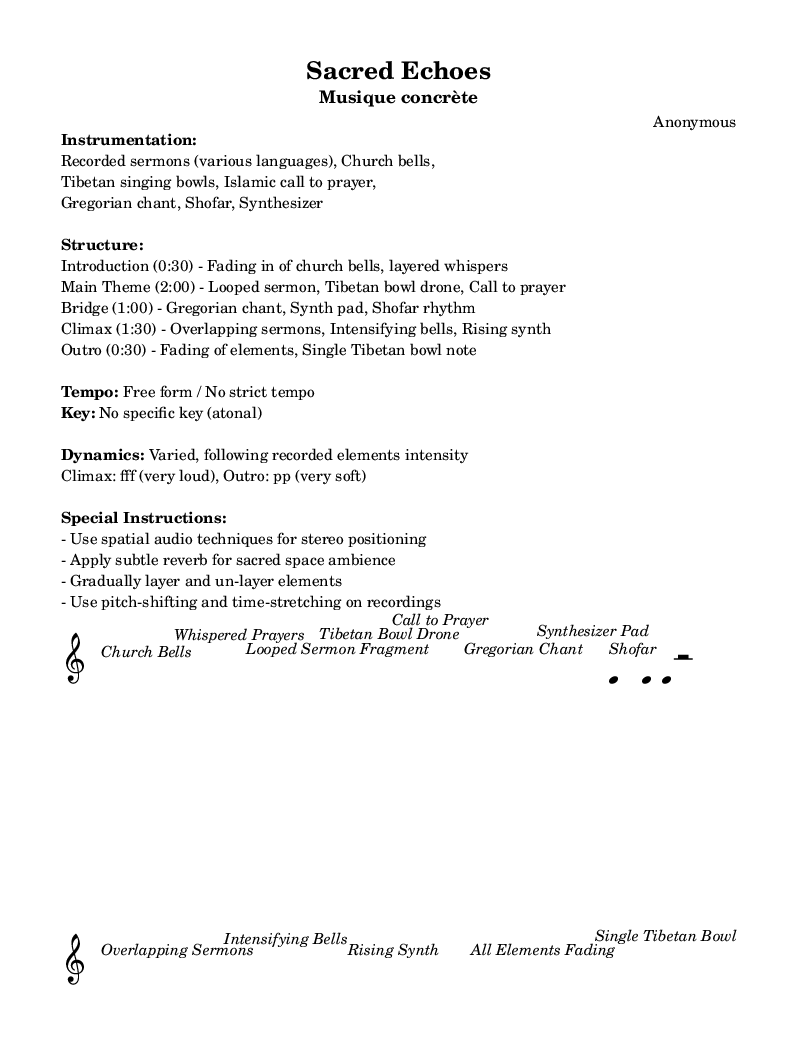what is the key signature of this music? The sheet music specifies that there is no specific key, indicating that it is atonal. Atonal music does not adhere to traditional key signatures.
Answer: No specific key what is the tempo of this piece? The score specifically mentions "Free form / No strict tempo," suggesting that the tempo is flexible and can vary throughout the piece without strict adherence to a rhythmic structure.
Answer: Free form how long is the introduction section? The introduction lasts for 30 seconds, as noted in the structure of the piece where it describes the sections and their respective durations.
Answer: 30 seconds which instruments are used in this piece? The instrumentation includes recorded sermons, church bells, Tibetan singing bowls, Islamic call to prayer, Gregorian chant, shofar, and synthesizer, which are explicitly listed in the markup at the beginning of the score.
Answer: Recorded sermons, Church bells, Tibetan singing bowls, Islamic call to prayer, Gregorian chant, Shofar, Synthesizer what is the dynamics during the climax of the piece? The climax section is noted to have a dynamic marking of "fff," meaning "fortissimo," which indicates that this section should be played very loudly. The explanation in the structure outlines the intensity of the pieces during this segment.
Answer: fff (very loud) what special audio techniques are suggested for this piece? The special instructions note several techniques including the use of spatial audio for stereo positioning, applying reverb for ambient effect, and techniques such as pitch-shifting and time-stretching, which helps create depth and texture in the soundscape.
Answer: Spatial audio techniques, reverb, pitch-shifting, time-stretching how does the outro of the piece conclude? The outro is described to involve the fading of all elements and a singular note from a Tibetan bowl, indicating a gradual diminishment that seeks to provide a tranquil conclusion to the sound.
Answer: Fading of elements, Single Tibetan bowl note 